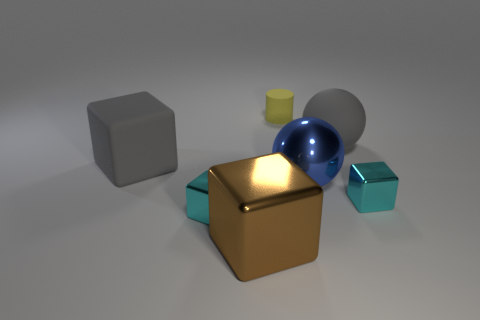Is the number of big cyan balls less than the number of tiny things?
Offer a very short reply. Yes. Are the tiny cyan block to the right of the big metal cube and the cylinder on the right side of the brown metallic object made of the same material?
Your answer should be compact. No. Are there fewer small cyan blocks that are to the left of the rubber cube than balls?
Make the answer very short. Yes. What number of blocks are in front of the large thing on the right side of the blue metal object?
Your answer should be very brief. 4. There is a rubber object that is both right of the large metallic cube and in front of the matte cylinder; what size is it?
Offer a terse response. Large. Are there any other things that have the same material as the big blue sphere?
Give a very brief answer. Yes. Is the brown object made of the same material as the big block that is behind the metal ball?
Keep it short and to the point. No. Are there fewer big gray cubes that are in front of the rubber cube than gray objects to the left of the brown thing?
Give a very brief answer. Yes. What material is the tiny cyan cube that is right of the blue object?
Offer a very short reply. Metal. There is a large object that is both on the left side of the yellow matte cylinder and in front of the matte block; what is its color?
Your answer should be compact. Brown. 